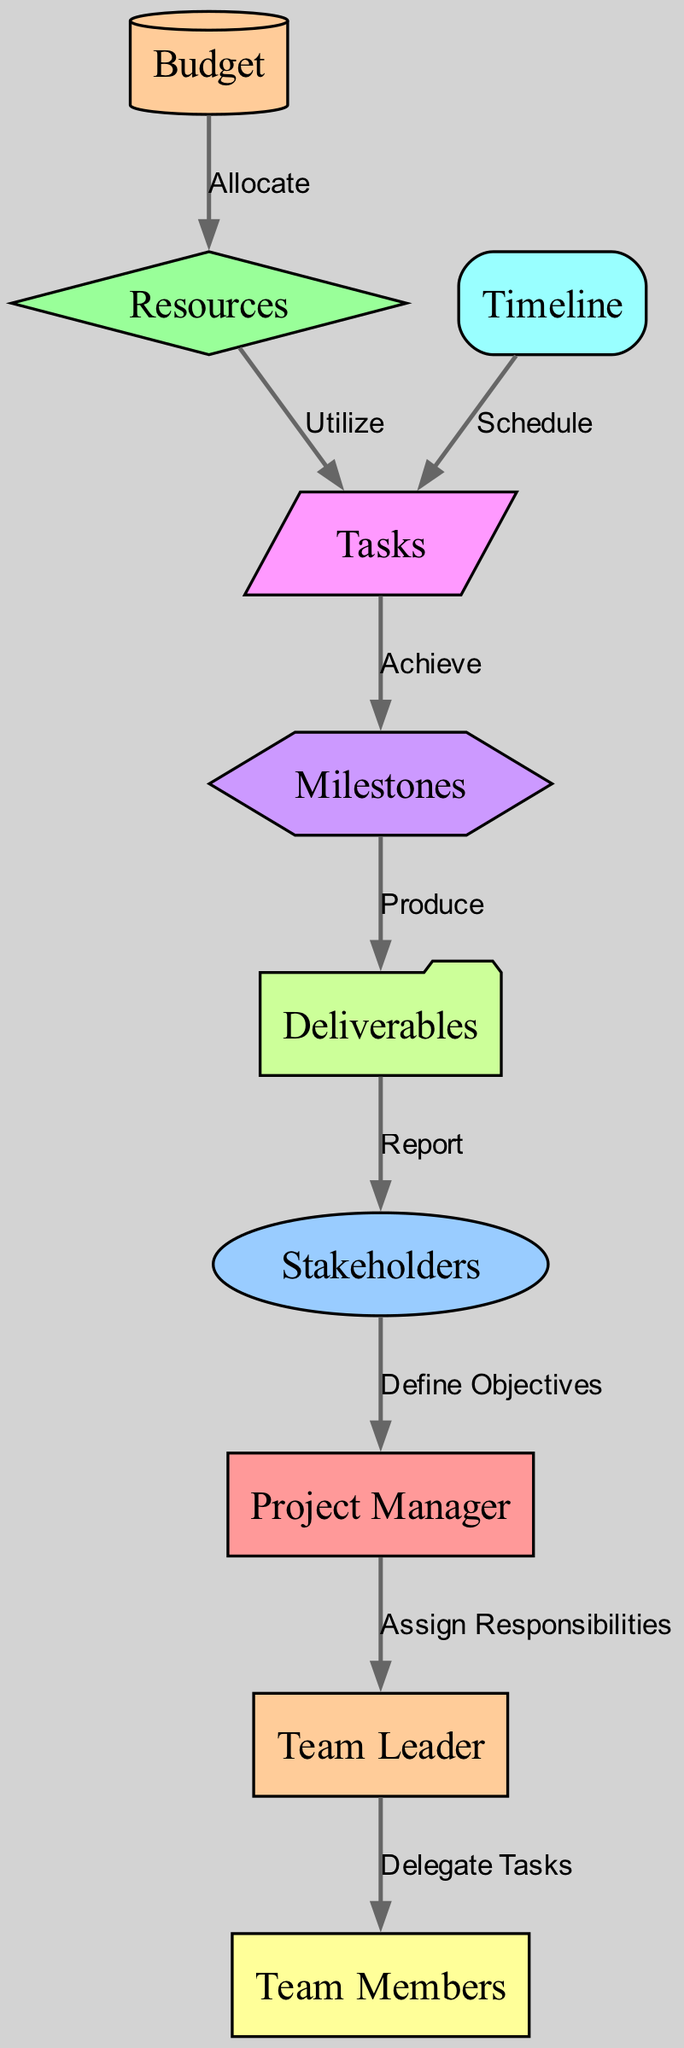What is the total number of nodes in the diagram? The diagram lists ten distinct nodes, each representing a different role or element in project management.
Answer: ten Who assigns responsibilities in the project management process? The edge labeled "Assign Responsibilities" indicates that the Project Manager is responsible for assigning responsibilities to the Team Leader.
Answer: Project Manager What type of relationship exists between Team Lead and Team Members? The edge labeled "Delegate Tasks" shows that the Team Lead delegates tasks to Team Members, indicating a directional relationship from Team Lead to Team Members.
Answer: Delegate Tasks Which node receives reports from Deliverables? The edge labeled "Report" identifies that Stakeholders receive reports from Deliverables, illustrating the flow of information.
Answer: Stakeholders How do resources relate to tasks? The edge labeled "Utilize" signifies that Tasks utilize Resources, indicating that tasks depend on the available resources to be completed.
Answer: Utilize What is the primary function of Milestones in the diagram? The edge labeled "Produce" indicates that Milestones lead to the production of Deliverables, highlighting their role in the project lifecycle.
Answer: Produce If the budget increases, what does it affect according to the diagram? The edge labeled "Allocate" from Budget to Resources indicates that an increase in Budget will allow for more Resources to be allocated to the project.
Answer: Resources What is the purpose of the Timeline in relation to Tasks? The edge labeled "Schedule" shows that the Timeline schedules the Tasks, meaning it organizes the tasks in accordance with the project timeline.
Answer: Schedule How many edges connect the nodes in the diagram? By counting every direct connection between the nodes, there are nine edges illustrated in the diagram that connect the various roles and elements.
Answer: nine 